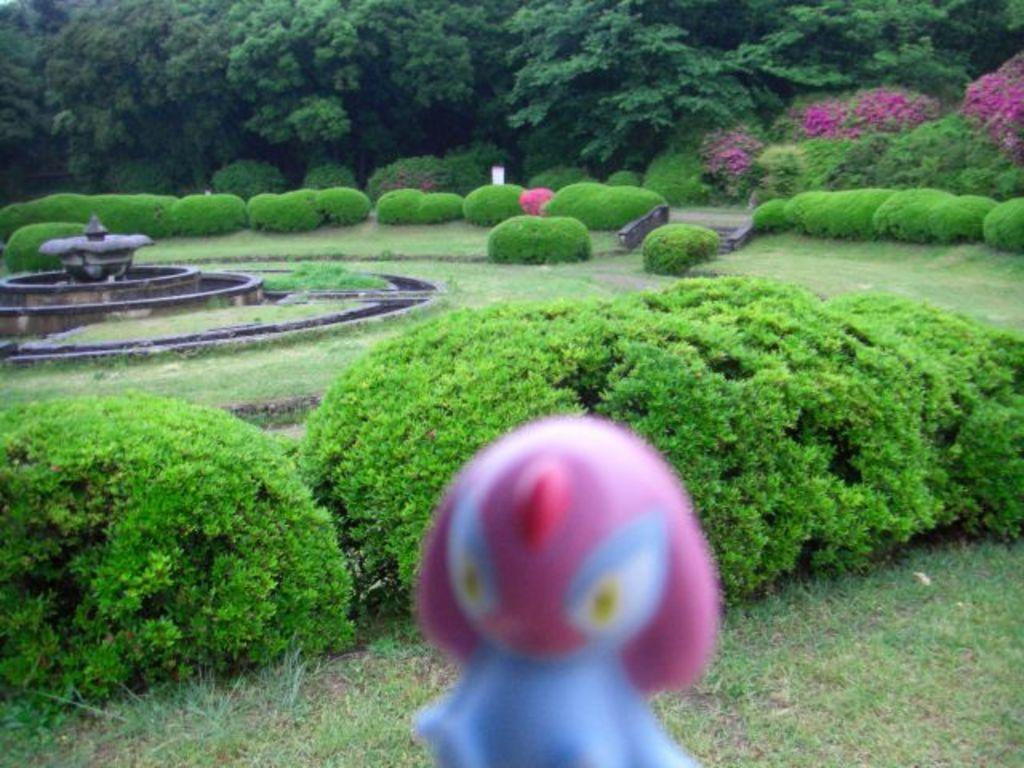What type of vegetation can be seen in the image? There are trees and bushes in the image. What architectural feature is present in the image? There are stairs in the image. What water feature can be seen in the image? There is a fountain in the image. What type of object is present that might be used for play? There is a toy in the image. What type of surface is visible in the image? There is ground visible in the image. What advice does the toy give to the fountain in the image? There is no interaction between the toy and the fountain in the image, and therefore no advice can be given. 